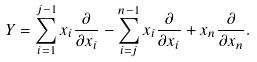Convert formula to latex. <formula><loc_0><loc_0><loc_500><loc_500>Y = \sum _ { i = 1 } ^ { j - 1 } x _ { i } \frac { \partial } { \partial x _ { i } } - \sum _ { i = j } ^ { n - 1 } x _ { i } \frac { \partial } { \partial x _ { i } } + x _ { n } \frac { \partial } { \partial x _ { n } } .</formula> 